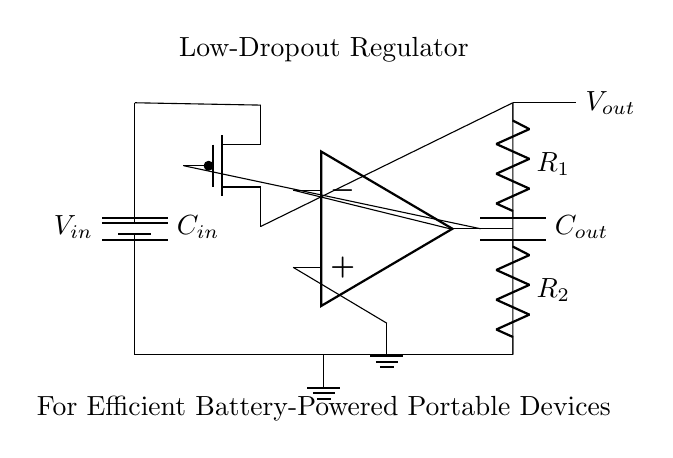What is the input voltage of the circuit? The input voltage is represented by \( V_{in} \) at the top of the battery symbol. It indicates the voltage supplied to the circuit from the battery.
Answer: V_{in} What type of transistor is used in this circuit? The circuit diagram shows a PMOS transistor, which is indicated by the shape of the transistor symbol labeled as "PMOS".
Answer: PMOS What is the purpose of the output capacitor, \( C_{out} \)? The output capacitor, shown at the output of the circuit, helps to stabilize the output voltage and filter noise, providing a smooth voltage level for connected devices.
Answer: Stabilization What are the values of the feedback resistors? The circuit has two feedback resistors, labeled as \( R_1 \) and \( R_2 \). The specific values are not given in the diagram itself, so they would need to be specified elsewhere.
Answer: Not specified How is the output voltage represented in the circuit? The output voltage is depicted on the right side of the diagram with the label \( V_{out} \), showing where the regulated output can be taken from.
Answer: V_{out} What is the function of the error amplifier in the circuit? The error amplifier's role is to compare the output voltage \( V_{out} \) with a reference voltage, adjusting the gate of the PMOS transistor to regulate the output voltage appropriately.
Answer: Voltage regulation What is the advantage of using a low-dropout regulator? The advantage of a low-dropout regulator is that it can maintain a regulated output voltage even when the input voltage is very close to the output voltage, which is crucial for efficient battery operation.
Answer: Efficiency 